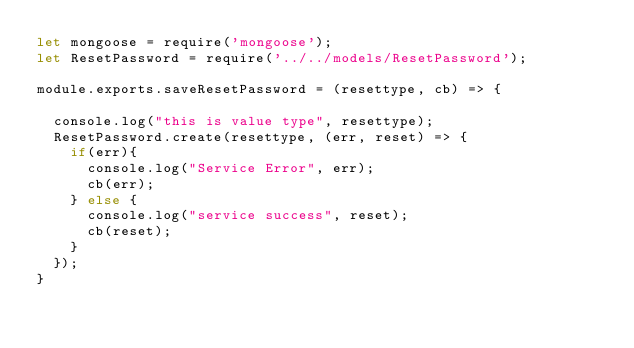<code> <loc_0><loc_0><loc_500><loc_500><_JavaScript_>let mongoose = require('mongoose');
let ResetPassword = require('../../models/ResetPassword');

module.exports.saveResetPassword = (resettype, cb) => {

  console.log("this is value type", resettype);
  ResetPassword.create(resettype, (err, reset) => {
    if(err){
      console.log("Service Error", err);
      cb(err);
    } else {
      console.log("service success", reset);
      cb(reset);
    }
  });
}
</code> 